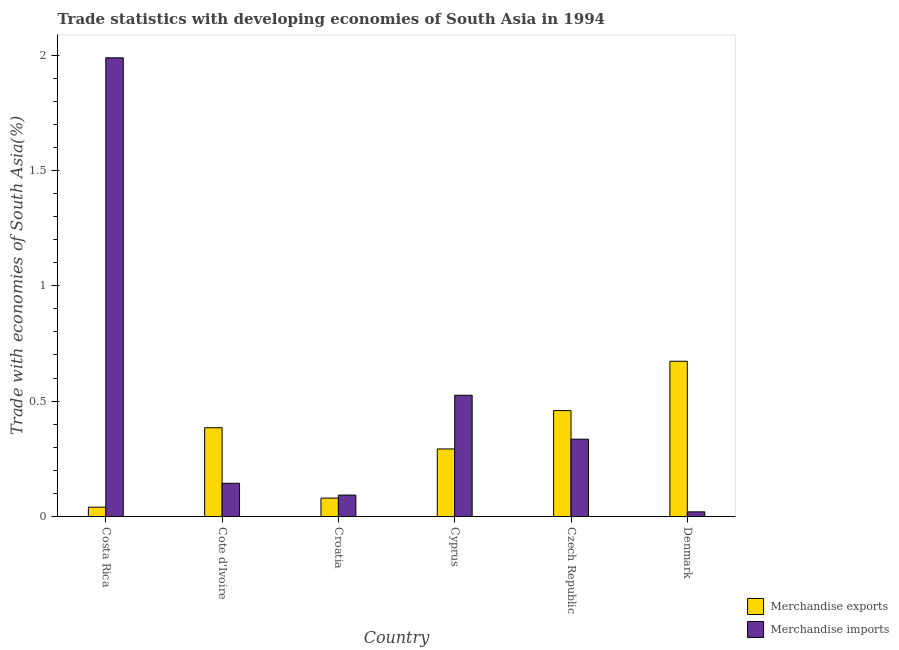How many different coloured bars are there?
Offer a very short reply. 2. How many groups of bars are there?
Provide a short and direct response. 6. Are the number of bars per tick equal to the number of legend labels?
Your answer should be compact. Yes. Are the number of bars on each tick of the X-axis equal?
Your answer should be very brief. Yes. What is the label of the 2nd group of bars from the left?
Offer a very short reply. Cote d'Ivoire. In how many cases, is the number of bars for a given country not equal to the number of legend labels?
Your response must be concise. 0. What is the merchandise imports in Czech Republic?
Keep it short and to the point. 0.34. Across all countries, what is the maximum merchandise imports?
Keep it short and to the point. 1.99. Across all countries, what is the minimum merchandise imports?
Your answer should be compact. 0.02. What is the total merchandise imports in the graph?
Make the answer very short. 3.11. What is the difference between the merchandise exports in Costa Rica and that in Croatia?
Make the answer very short. -0.04. What is the difference between the merchandise exports in Cyprus and the merchandise imports in Cote d'Ivoire?
Provide a short and direct response. 0.15. What is the average merchandise exports per country?
Provide a succinct answer. 0.32. What is the difference between the merchandise imports and merchandise exports in Czech Republic?
Your answer should be very brief. -0.12. In how many countries, is the merchandise imports greater than 1.6 %?
Keep it short and to the point. 1. What is the ratio of the merchandise exports in Costa Rica to that in Cote d'Ivoire?
Provide a short and direct response. 0.1. Is the difference between the merchandise imports in Cote d'Ivoire and Croatia greater than the difference between the merchandise exports in Cote d'Ivoire and Croatia?
Your answer should be compact. No. What is the difference between the highest and the second highest merchandise exports?
Offer a terse response. 0.21. What is the difference between the highest and the lowest merchandise imports?
Ensure brevity in your answer.  1.97. What does the 1st bar from the left in Cyprus represents?
Provide a succinct answer. Merchandise exports. How many bars are there?
Your answer should be very brief. 12. Does the graph contain any zero values?
Your response must be concise. No. How are the legend labels stacked?
Make the answer very short. Vertical. What is the title of the graph?
Provide a short and direct response. Trade statistics with developing economies of South Asia in 1994. Does "Research and Development" appear as one of the legend labels in the graph?
Offer a terse response. No. What is the label or title of the X-axis?
Your response must be concise. Country. What is the label or title of the Y-axis?
Your answer should be very brief. Trade with economies of South Asia(%). What is the Trade with economies of South Asia(%) of Merchandise exports in Costa Rica?
Your answer should be compact. 0.04. What is the Trade with economies of South Asia(%) of Merchandise imports in Costa Rica?
Give a very brief answer. 1.99. What is the Trade with economies of South Asia(%) in Merchandise exports in Cote d'Ivoire?
Provide a short and direct response. 0.38. What is the Trade with economies of South Asia(%) of Merchandise imports in Cote d'Ivoire?
Keep it short and to the point. 0.14. What is the Trade with economies of South Asia(%) in Merchandise exports in Croatia?
Your answer should be compact. 0.08. What is the Trade with economies of South Asia(%) of Merchandise imports in Croatia?
Offer a very short reply. 0.09. What is the Trade with economies of South Asia(%) in Merchandise exports in Cyprus?
Provide a succinct answer. 0.29. What is the Trade with economies of South Asia(%) in Merchandise imports in Cyprus?
Ensure brevity in your answer.  0.53. What is the Trade with economies of South Asia(%) of Merchandise exports in Czech Republic?
Make the answer very short. 0.46. What is the Trade with economies of South Asia(%) in Merchandise imports in Czech Republic?
Your response must be concise. 0.34. What is the Trade with economies of South Asia(%) in Merchandise exports in Denmark?
Make the answer very short. 0.67. What is the Trade with economies of South Asia(%) of Merchandise imports in Denmark?
Your response must be concise. 0.02. Across all countries, what is the maximum Trade with economies of South Asia(%) in Merchandise exports?
Your answer should be compact. 0.67. Across all countries, what is the maximum Trade with economies of South Asia(%) in Merchandise imports?
Provide a short and direct response. 1.99. Across all countries, what is the minimum Trade with economies of South Asia(%) in Merchandise exports?
Provide a succinct answer. 0.04. Across all countries, what is the minimum Trade with economies of South Asia(%) of Merchandise imports?
Your answer should be compact. 0.02. What is the total Trade with economies of South Asia(%) in Merchandise exports in the graph?
Keep it short and to the point. 1.93. What is the total Trade with economies of South Asia(%) of Merchandise imports in the graph?
Your answer should be compact. 3.11. What is the difference between the Trade with economies of South Asia(%) in Merchandise exports in Costa Rica and that in Cote d'Ivoire?
Offer a terse response. -0.34. What is the difference between the Trade with economies of South Asia(%) in Merchandise imports in Costa Rica and that in Cote d'Ivoire?
Your response must be concise. 1.84. What is the difference between the Trade with economies of South Asia(%) in Merchandise exports in Costa Rica and that in Croatia?
Ensure brevity in your answer.  -0.04. What is the difference between the Trade with economies of South Asia(%) of Merchandise imports in Costa Rica and that in Croatia?
Keep it short and to the point. 1.9. What is the difference between the Trade with economies of South Asia(%) in Merchandise exports in Costa Rica and that in Cyprus?
Offer a very short reply. -0.25. What is the difference between the Trade with economies of South Asia(%) of Merchandise imports in Costa Rica and that in Cyprus?
Offer a very short reply. 1.46. What is the difference between the Trade with economies of South Asia(%) in Merchandise exports in Costa Rica and that in Czech Republic?
Your response must be concise. -0.42. What is the difference between the Trade with economies of South Asia(%) in Merchandise imports in Costa Rica and that in Czech Republic?
Keep it short and to the point. 1.65. What is the difference between the Trade with economies of South Asia(%) of Merchandise exports in Costa Rica and that in Denmark?
Provide a succinct answer. -0.63. What is the difference between the Trade with economies of South Asia(%) in Merchandise imports in Costa Rica and that in Denmark?
Provide a short and direct response. 1.97. What is the difference between the Trade with economies of South Asia(%) of Merchandise exports in Cote d'Ivoire and that in Croatia?
Offer a terse response. 0.3. What is the difference between the Trade with economies of South Asia(%) in Merchandise imports in Cote d'Ivoire and that in Croatia?
Provide a short and direct response. 0.05. What is the difference between the Trade with economies of South Asia(%) in Merchandise exports in Cote d'Ivoire and that in Cyprus?
Your response must be concise. 0.09. What is the difference between the Trade with economies of South Asia(%) of Merchandise imports in Cote d'Ivoire and that in Cyprus?
Make the answer very short. -0.38. What is the difference between the Trade with economies of South Asia(%) of Merchandise exports in Cote d'Ivoire and that in Czech Republic?
Offer a very short reply. -0.07. What is the difference between the Trade with economies of South Asia(%) of Merchandise imports in Cote d'Ivoire and that in Czech Republic?
Give a very brief answer. -0.19. What is the difference between the Trade with economies of South Asia(%) in Merchandise exports in Cote d'Ivoire and that in Denmark?
Keep it short and to the point. -0.29. What is the difference between the Trade with economies of South Asia(%) of Merchandise imports in Cote d'Ivoire and that in Denmark?
Your response must be concise. 0.12. What is the difference between the Trade with economies of South Asia(%) in Merchandise exports in Croatia and that in Cyprus?
Keep it short and to the point. -0.21. What is the difference between the Trade with economies of South Asia(%) in Merchandise imports in Croatia and that in Cyprus?
Keep it short and to the point. -0.43. What is the difference between the Trade with economies of South Asia(%) in Merchandise exports in Croatia and that in Czech Republic?
Your response must be concise. -0.38. What is the difference between the Trade with economies of South Asia(%) in Merchandise imports in Croatia and that in Czech Republic?
Your answer should be compact. -0.24. What is the difference between the Trade with economies of South Asia(%) in Merchandise exports in Croatia and that in Denmark?
Your answer should be compact. -0.59. What is the difference between the Trade with economies of South Asia(%) in Merchandise imports in Croatia and that in Denmark?
Ensure brevity in your answer.  0.07. What is the difference between the Trade with economies of South Asia(%) in Merchandise exports in Cyprus and that in Czech Republic?
Your answer should be compact. -0.17. What is the difference between the Trade with economies of South Asia(%) in Merchandise imports in Cyprus and that in Czech Republic?
Make the answer very short. 0.19. What is the difference between the Trade with economies of South Asia(%) of Merchandise exports in Cyprus and that in Denmark?
Ensure brevity in your answer.  -0.38. What is the difference between the Trade with economies of South Asia(%) in Merchandise imports in Cyprus and that in Denmark?
Keep it short and to the point. 0.51. What is the difference between the Trade with economies of South Asia(%) in Merchandise exports in Czech Republic and that in Denmark?
Your answer should be very brief. -0.21. What is the difference between the Trade with economies of South Asia(%) of Merchandise imports in Czech Republic and that in Denmark?
Give a very brief answer. 0.31. What is the difference between the Trade with economies of South Asia(%) in Merchandise exports in Costa Rica and the Trade with economies of South Asia(%) in Merchandise imports in Cote d'Ivoire?
Ensure brevity in your answer.  -0.1. What is the difference between the Trade with economies of South Asia(%) of Merchandise exports in Costa Rica and the Trade with economies of South Asia(%) of Merchandise imports in Croatia?
Your response must be concise. -0.05. What is the difference between the Trade with economies of South Asia(%) of Merchandise exports in Costa Rica and the Trade with economies of South Asia(%) of Merchandise imports in Cyprus?
Your response must be concise. -0.49. What is the difference between the Trade with economies of South Asia(%) in Merchandise exports in Costa Rica and the Trade with economies of South Asia(%) in Merchandise imports in Czech Republic?
Offer a terse response. -0.29. What is the difference between the Trade with economies of South Asia(%) of Merchandise exports in Costa Rica and the Trade with economies of South Asia(%) of Merchandise imports in Denmark?
Provide a short and direct response. 0.02. What is the difference between the Trade with economies of South Asia(%) of Merchandise exports in Cote d'Ivoire and the Trade with economies of South Asia(%) of Merchandise imports in Croatia?
Keep it short and to the point. 0.29. What is the difference between the Trade with economies of South Asia(%) of Merchandise exports in Cote d'Ivoire and the Trade with economies of South Asia(%) of Merchandise imports in Cyprus?
Your response must be concise. -0.14. What is the difference between the Trade with economies of South Asia(%) of Merchandise exports in Cote d'Ivoire and the Trade with economies of South Asia(%) of Merchandise imports in Czech Republic?
Offer a terse response. 0.05. What is the difference between the Trade with economies of South Asia(%) of Merchandise exports in Cote d'Ivoire and the Trade with economies of South Asia(%) of Merchandise imports in Denmark?
Your response must be concise. 0.36. What is the difference between the Trade with economies of South Asia(%) of Merchandise exports in Croatia and the Trade with economies of South Asia(%) of Merchandise imports in Cyprus?
Offer a terse response. -0.45. What is the difference between the Trade with economies of South Asia(%) in Merchandise exports in Croatia and the Trade with economies of South Asia(%) in Merchandise imports in Czech Republic?
Give a very brief answer. -0.26. What is the difference between the Trade with economies of South Asia(%) in Merchandise exports in Croatia and the Trade with economies of South Asia(%) in Merchandise imports in Denmark?
Ensure brevity in your answer.  0.06. What is the difference between the Trade with economies of South Asia(%) in Merchandise exports in Cyprus and the Trade with economies of South Asia(%) in Merchandise imports in Czech Republic?
Give a very brief answer. -0.04. What is the difference between the Trade with economies of South Asia(%) in Merchandise exports in Cyprus and the Trade with economies of South Asia(%) in Merchandise imports in Denmark?
Your answer should be compact. 0.27. What is the difference between the Trade with economies of South Asia(%) of Merchandise exports in Czech Republic and the Trade with economies of South Asia(%) of Merchandise imports in Denmark?
Keep it short and to the point. 0.44. What is the average Trade with economies of South Asia(%) of Merchandise exports per country?
Ensure brevity in your answer.  0.32. What is the average Trade with economies of South Asia(%) in Merchandise imports per country?
Offer a very short reply. 0.52. What is the difference between the Trade with economies of South Asia(%) of Merchandise exports and Trade with economies of South Asia(%) of Merchandise imports in Costa Rica?
Your response must be concise. -1.95. What is the difference between the Trade with economies of South Asia(%) in Merchandise exports and Trade with economies of South Asia(%) in Merchandise imports in Cote d'Ivoire?
Your response must be concise. 0.24. What is the difference between the Trade with economies of South Asia(%) in Merchandise exports and Trade with economies of South Asia(%) in Merchandise imports in Croatia?
Make the answer very short. -0.01. What is the difference between the Trade with economies of South Asia(%) of Merchandise exports and Trade with economies of South Asia(%) of Merchandise imports in Cyprus?
Your answer should be compact. -0.23. What is the difference between the Trade with economies of South Asia(%) of Merchandise exports and Trade with economies of South Asia(%) of Merchandise imports in Czech Republic?
Ensure brevity in your answer.  0.12. What is the difference between the Trade with economies of South Asia(%) of Merchandise exports and Trade with economies of South Asia(%) of Merchandise imports in Denmark?
Keep it short and to the point. 0.65. What is the ratio of the Trade with economies of South Asia(%) in Merchandise exports in Costa Rica to that in Cote d'Ivoire?
Provide a short and direct response. 0.1. What is the ratio of the Trade with economies of South Asia(%) of Merchandise imports in Costa Rica to that in Cote d'Ivoire?
Give a very brief answer. 13.81. What is the ratio of the Trade with economies of South Asia(%) in Merchandise exports in Costa Rica to that in Croatia?
Provide a short and direct response. 0.51. What is the ratio of the Trade with economies of South Asia(%) of Merchandise imports in Costa Rica to that in Croatia?
Ensure brevity in your answer.  21.43. What is the ratio of the Trade with economies of South Asia(%) of Merchandise exports in Costa Rica to that in Cyprus?
Keep it short and to the point. 0.14. What is the ratio of the Trade with economies of South Asia(%) in Merchandise imports in Costa Rica to that in Cyprus?
Ensure brevity in your answer.  3.78. What is the ratio of the Trade with economies of South Asia(%) of Merchandise exports in Costa Rica to that in Czech Republic?
Keep it short and to the point. 0.09. What is the ratio of the Trade with economies of South Asia(%) in Merchandise imports in Costa Rica to that in Czech Republic?
Your response must be concise. 5.93. What is the ratio of the Trade with economies of South Asia(%) of Merchandise imports in Costa Rica to that in Denmark?
Give a very brief answer. 98.58. What is the ratio of the Trade with economies of South Asia(%) of Merchandise exports in Cote d'Ivoire to that in Croatia?
Offer a terse response. 4.83. What is the ratio of the Trade with economies of South Asia(%) of Merchandise imports in Cote d'Ivoire to that in Croatia?
Provide a succinct answer. 1.55. What is the ratio of the Trade with economies of South Asia(%) in Merchandise exports in Cote d'Ivoire to that in Cyprus?
Keep it short and to the point. 1.31. What is the ratio of the Trade with economies of South Asia(%) of Merchandise imports in Cote d'Ivoire to that in Cyprus?
Keep it short and to the point. 0.27. What is the ratio of the Trade with economies of South Asia(%) of Merchandise exports in Cote d'Ivoire to that in Czech Republic?
Offer a terse response. 0.84. What is the ratio of the Trade with economies of South Asia(%) of Merchandise imports in Cote d'Ivoire to that in Czech Republic?
Provide a succinct answer. 0.43. What is the ratio of the Trade with economies of South Asia(%) in Merchandise exports in Cote d'Ivoire to that in Denmark?
Your answer should be very brief. 0.57. What is the ratio of the Trade with economies of South Asia(%) of Merchandise imports in Cote d'Ivoire to that in Denmark?
Your response must be concise. 7.14. What is the ratio of the Trade with economies of South Asia(%) in Merchandise exports in Croatia to that in Cyprus?
Your answer should be very brief. 0.27. What is the ratio of the Trade with economies of South Asia(%) of Merchandise imports in Croatia to that in Cyprus?
Provide a short and direct response. 0.18. What is the ratio of the Trade with economies of South Asia(%) in Merchandise exports in Croatia to that in Czech Republic?
Your response must be concise. 0.17. What is the ratio of the Trade with economies of South Asia(%) of Merchandise imports in Croatia to that in Czech Republic?
Your answer should be very brief. 0.28. What is the ratio of the Trade with economies of South Asia(%) in Merchandise exports in Croatia to that in Denmark?
Your response must be concise. 0.12. What is the ratio of the Trade with economies of South Asia(%) of Merchandise imports in Croatia to that in Denmark?
Ensure brevity in your answer.  4.6. What is the ratio of the Trade with economies of South Asia(%) in Merchandise exports in Cyprus to that in Czech Republic?
Your answer should be compact. 0.64. What is the ratio of the Trade with economies of South Asia(%) in Merchandise imports in Cyprus to that in Czech Republic?
Your answer should be compact. 1.57. What is the ratio of the Trade with economies of South Asia(%) of Merchandise exports in Cyprus to that in Denmark?
Offer a terse response. 0.43. What is the ratio of the Trade with economies of South Asia(%) in Merchandise imports in Cyprus to that in Denmark?
Offer a terse response. 26.06. What is the ratio of the Trade with economies of South Asia(%) in Merchandise exports in Czech Republic to that in Denmark?
Your response must be concise. 0.68. What is the ratio of the Trade with economies of South Asia(%) in Merchandise imports in Czech Republic to that in Denmark?
Your response must be concise. 16.61. What is the difference between the highest and the second highest Trade with economies of South Asia(%) of Merchandise exports?
Your response must be concise. 0.21. What is the difference between the highest and the second highest Trade with economies of South Asia(%) in Merchandise imports?
Provide a short and direct response. 1.46. What is the difference between the highest and the lowest Trade with economies of South Asia(%) of Merchandise exports?
Offer a very short reply. 0.63. What is the difference between the highest and the lowest Trade with economies of South Asia(%) of Merchandise imports?
Ensure brevity in your answer.  1.97. 